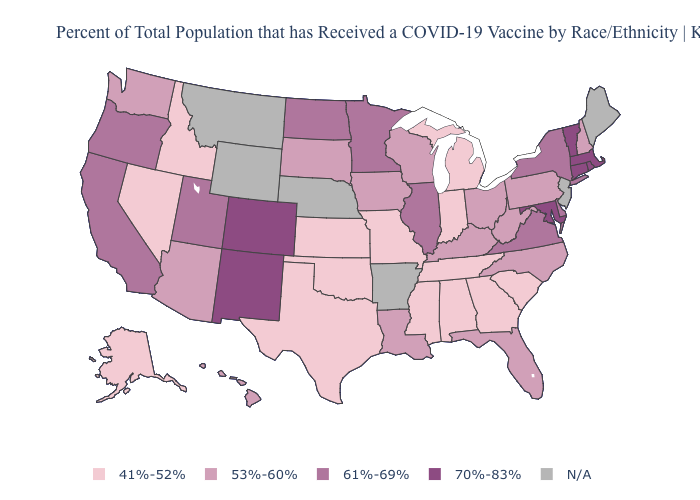Among the states that border South Dakota , does Iowa have the lowest value?
Give a very brief answer. Yes. Does the first symbol in the legend represent the smallest category?
Answer briefly. Yes. Does the map have missing data?
Short answer required. Yes. Among the states that border Montana , which have the lowest value?
Answer briefly. Idaho. What is the lowest value in the USA?
Keep it brief. 41%-52%. What is the lowest value in the MidWest?
Give a very brief answer. 41%-52%. What is the value of Minnesota?
Concise answer only. 61%-69%. What is the value of Nebraska?
Keep it brief. N/A. Among the states that border Vermont , does New Hampshire have the highest value?
Write a very short answer. No. Does the first symbol in the legend represent the smallest category?
Be succinct. Yes. Among the states that border Kentucky , does Virginia have the lowest value?
Keep it brief. No. What is the value of New Mexico?
Keep it brief. 70%-83%. Does Nevada have the highest value in the West?
Give a very brief answer. No. 